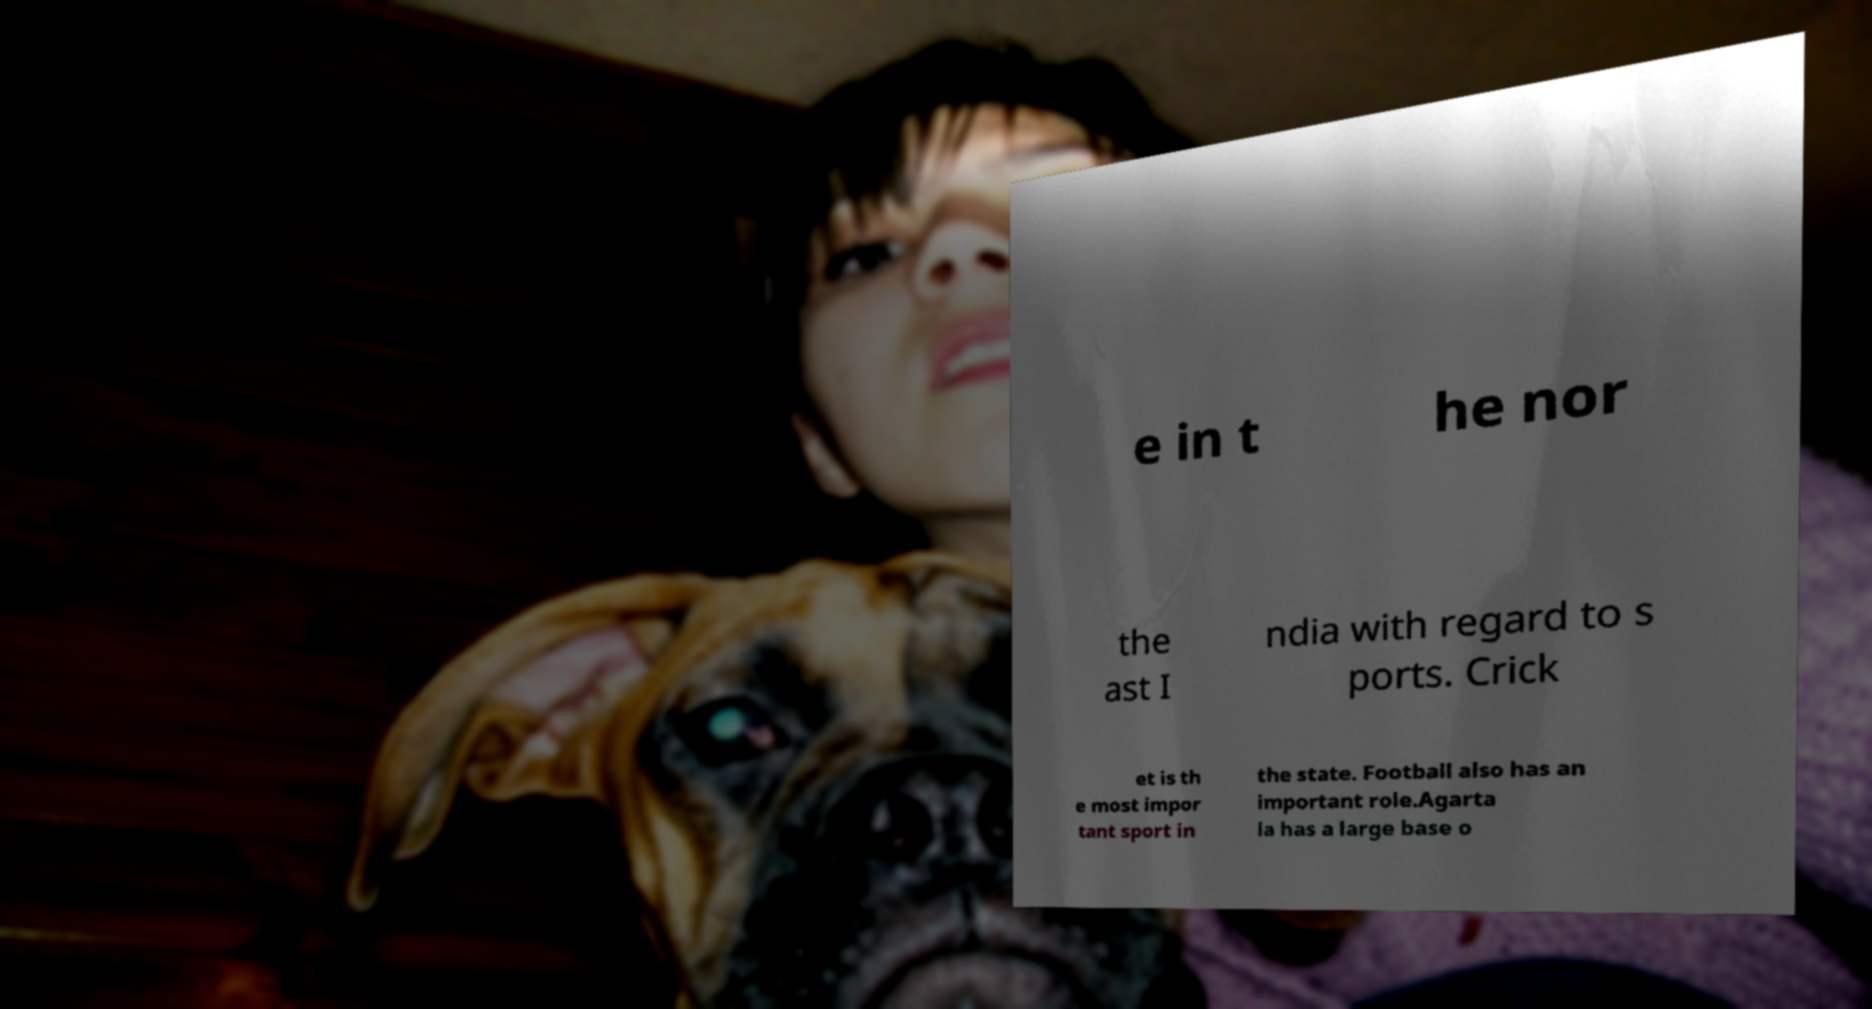Can you read and provide the text displayed in the image?This photo seems to have some interesting text. Can you extract and type it out for me? e in t he nor the ast I ndia with regard to s ports. Crick et is th e most impor tant sport in the state. Football also has an important role.Agarta la has a large base o 